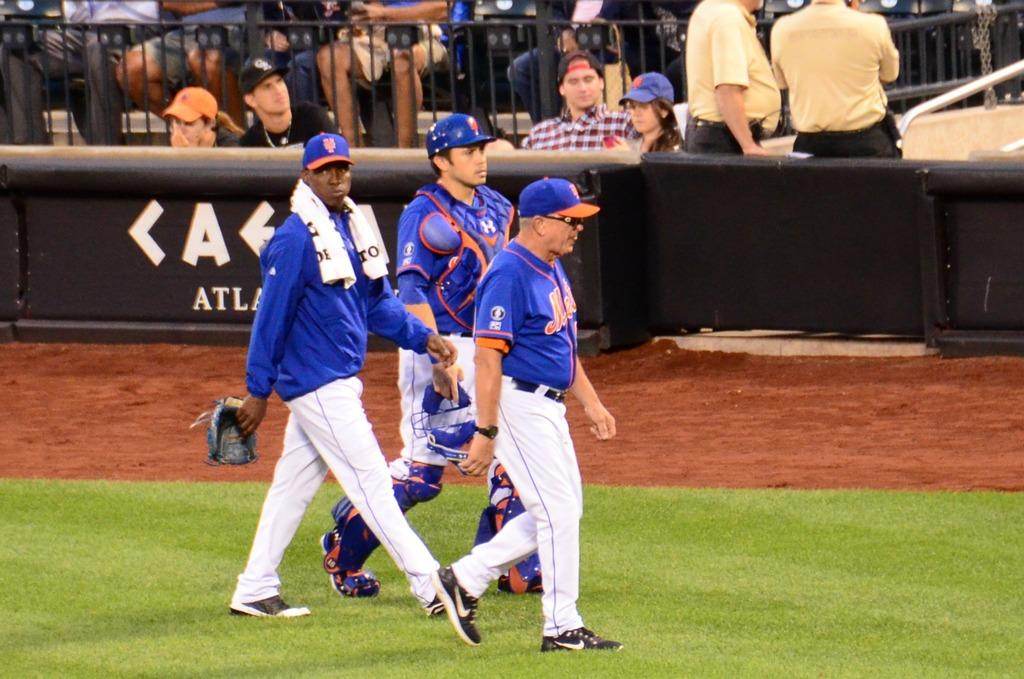Provide a one-sentence caption for the provided image. Mets players and personnel make their way across the baseball field. 